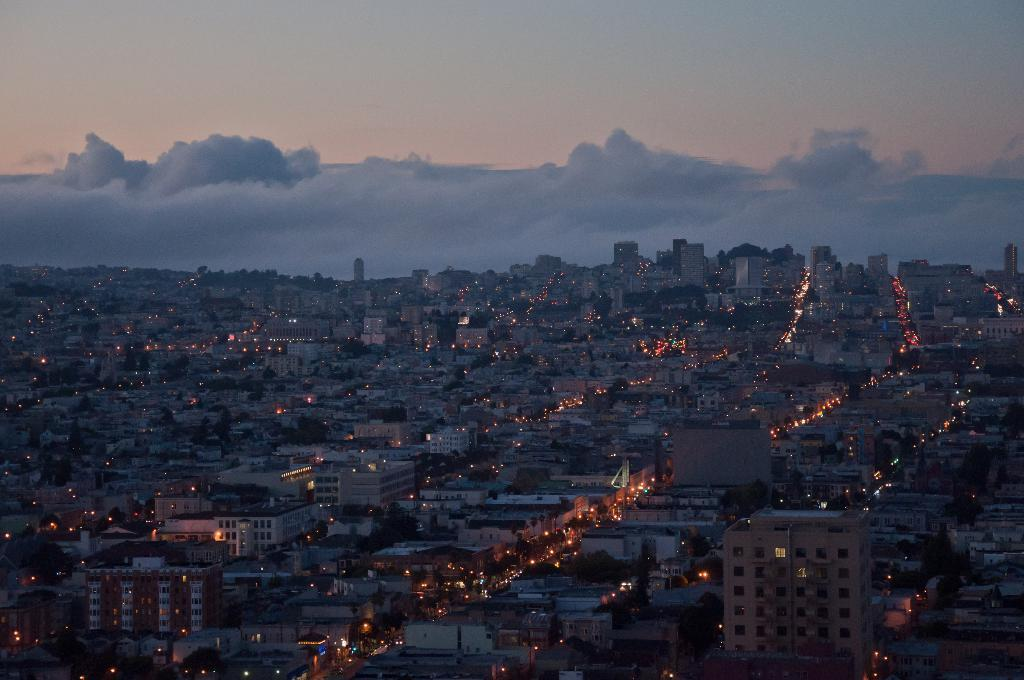What type of structures can be seen in the image? There are houses and buildings in the image. Are there any visible sources of light in the image? Yes, there are lights visible in the image. What can be seen in the background of the image? There is a sky with clouds in the background of the image. What type of knife is the father using in the image? There is no knife or father present in the image. What company is responsible for the construction of the buildings in the image? The image does not provide information about the company responsible for the construction of the buildings. 